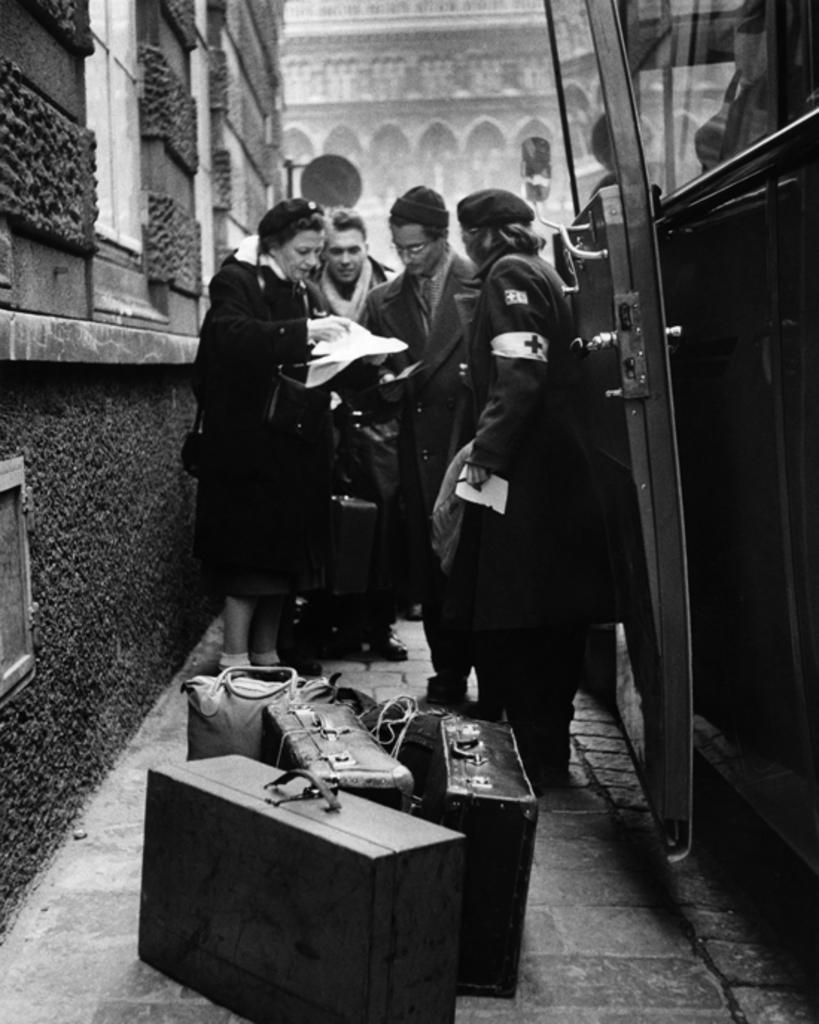How would you summarize this image in a sentence or two? In this image there are four members who are standing on the left side there is one woman who is standing and she is holding a paper and on the left side there is wall and on the right side there is one vehicle on the background there is one window and in the bottom of the image there are luggage and backpacks are there on the floor 